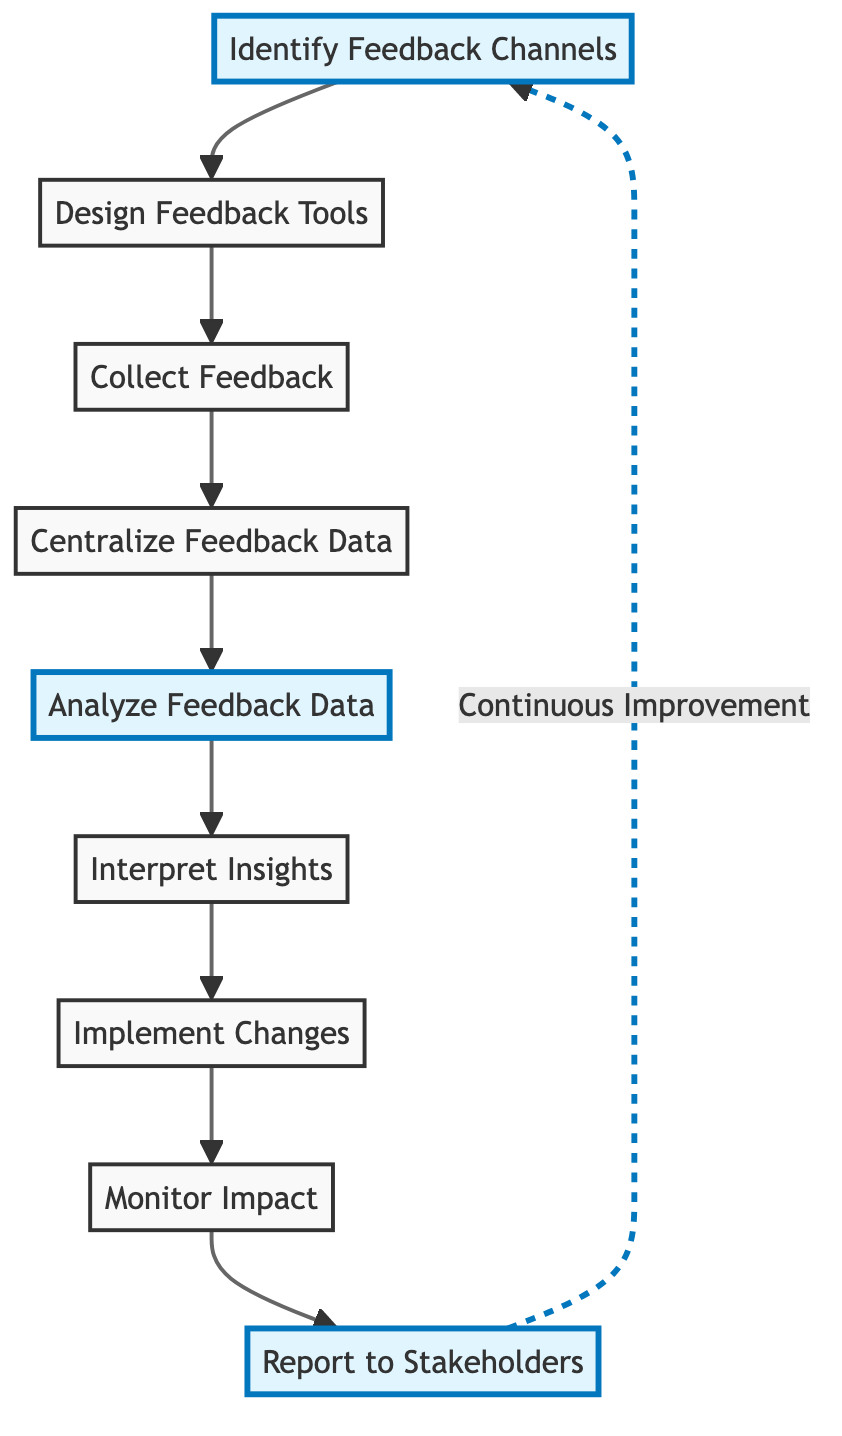What is the first step in the process? The first step in the process is identified directly from the diagram, where it shows "Identify Feedback Channels" as the initial node.
Answer: Identify Feedback Channels How many steps are there in total? By counting the nodes listed in the diagram, we can see that there are a total of nine distinct steps.
Answer: 9 What do we do after collecting feedback? The flowchart indicates that after collecting feedback (step 3), the next step is to "Centralize Feedback Data" (step 4).
Answer: Centralize Feedback Data Which step follows "Analyze Feedback Data"? According to the flowchart, the step that follows "Analyze Feedback Data" (step 5) is "Interpret Insights" (step 6), making it the next process stage.
Answer: Interpret Insights What is the main purpose of "Interpret Insights"? The diagram states that the purpose of "Interpret Insights" is to translate analysis results into actionable insights, which helps improve services based on customer feedback.
Answer: Translate analysis results into actionable insights In which step do we monitor the impact of changes? From the flowchart, the step dedicated to monitoring the impact of changes occurs after implementing them, specifically in "Monitor Impact" (step 8).
Answer: Monitor Impact What connects "Report to Stakeholders" and "Identify Feedback Channels"? The diagram shows a continuous loop between "Report to Stakeholders" and "Identify Feedback Channels," indicating a cycle of continuous improvement based on feedback.
Answer: Continuous Improvement How are feedback tools designed? Based on the flowchart, feedback tools are designed (step 2) to ensure they are user-friendly and easy to understand, facilitating better customer responses.
Answer: User-friendly and easy to understand What happens after implementing changes? After implementing changes (step 7), the flowchart specifies that the next action is to "Monitor Impact" to evaluate the effectiveness of those changes.
Answer: Monitor Impact 